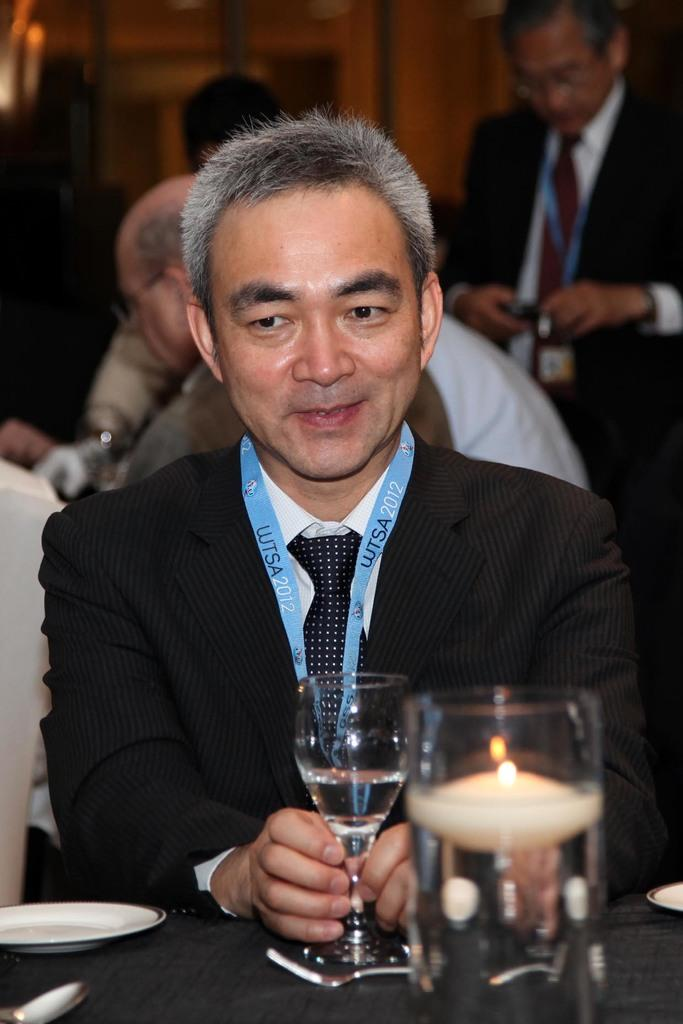What is the person holding in the image? The person is holding a glass in the image. What else can be seen on the table in the image? There is a plate and a spoon visible on the table in the image. What additional item is present on the table? There is a candle on the table in the image. What is the general setting of the image? There are objects on the table and people visible in the background of the image. Can you see a goat in the image? No, there is no goat present in the image. What type of quill is being used to copy the document in the image? There is no document or quill visible in the image. 